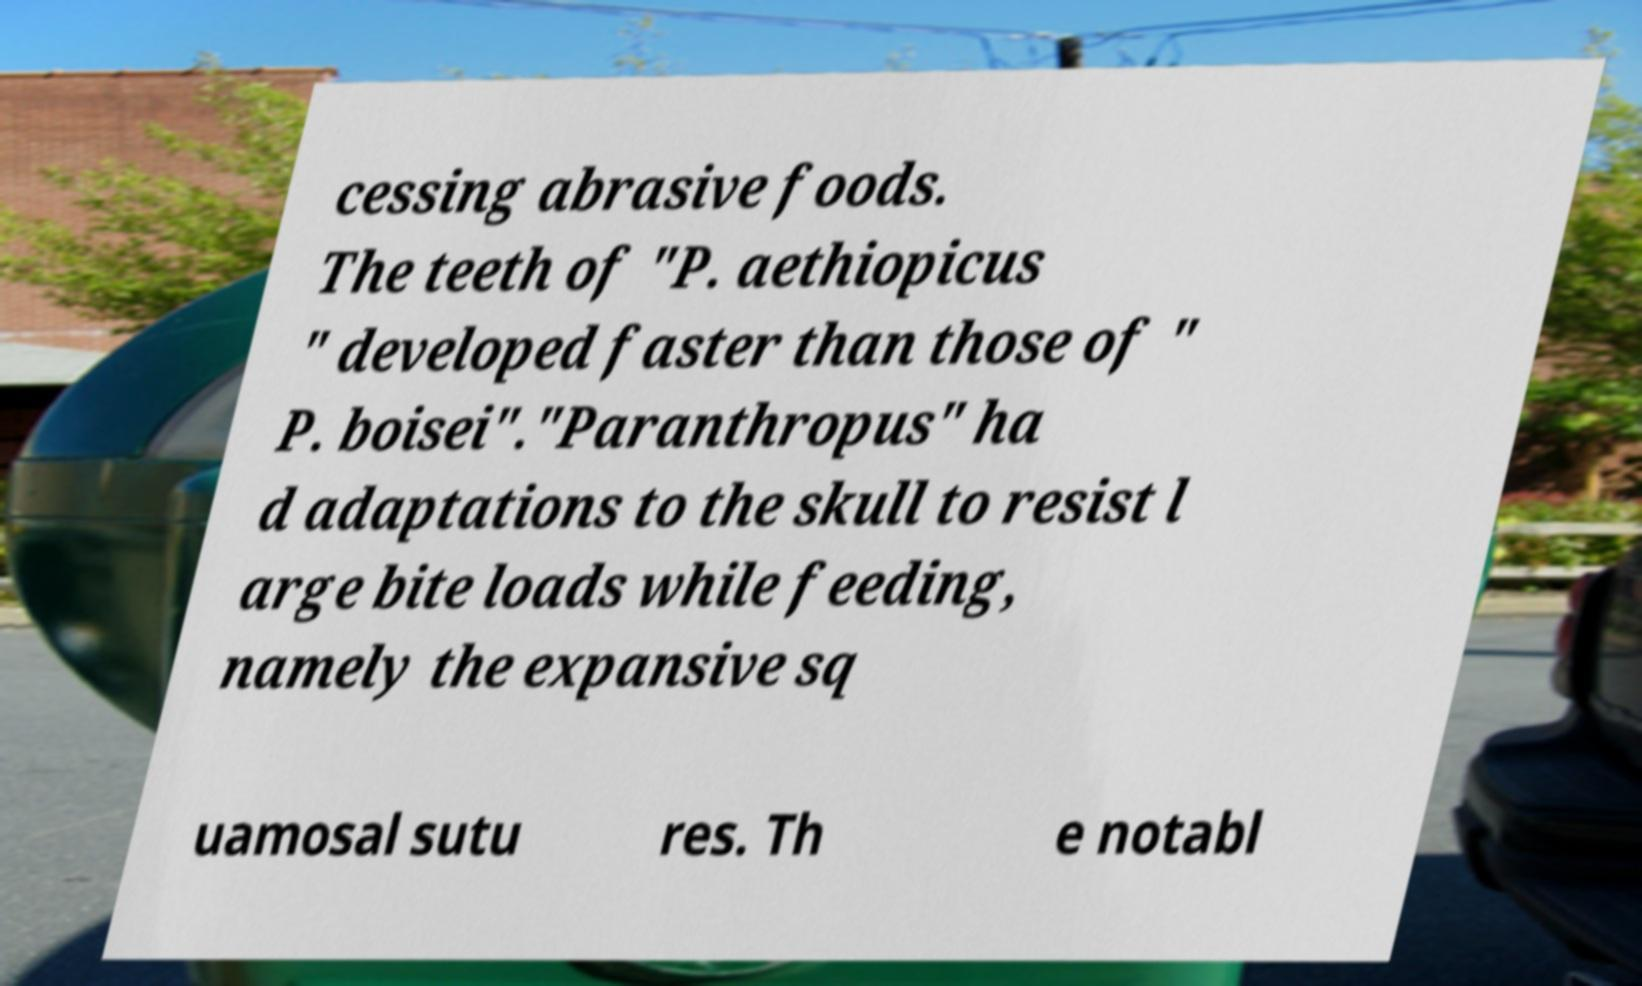There's text embedded in this image that I need extracted. Can you transcribe it verbatim? cessing abrasive foods. The teeth of "P. aethiopicus " developed faster than those of " P. boisei"."Paranthropus" ha d adaptations to the skull to resist l arge bite loads while feeding, namely the expansive sq uamosal sutu res. Th e notabl 